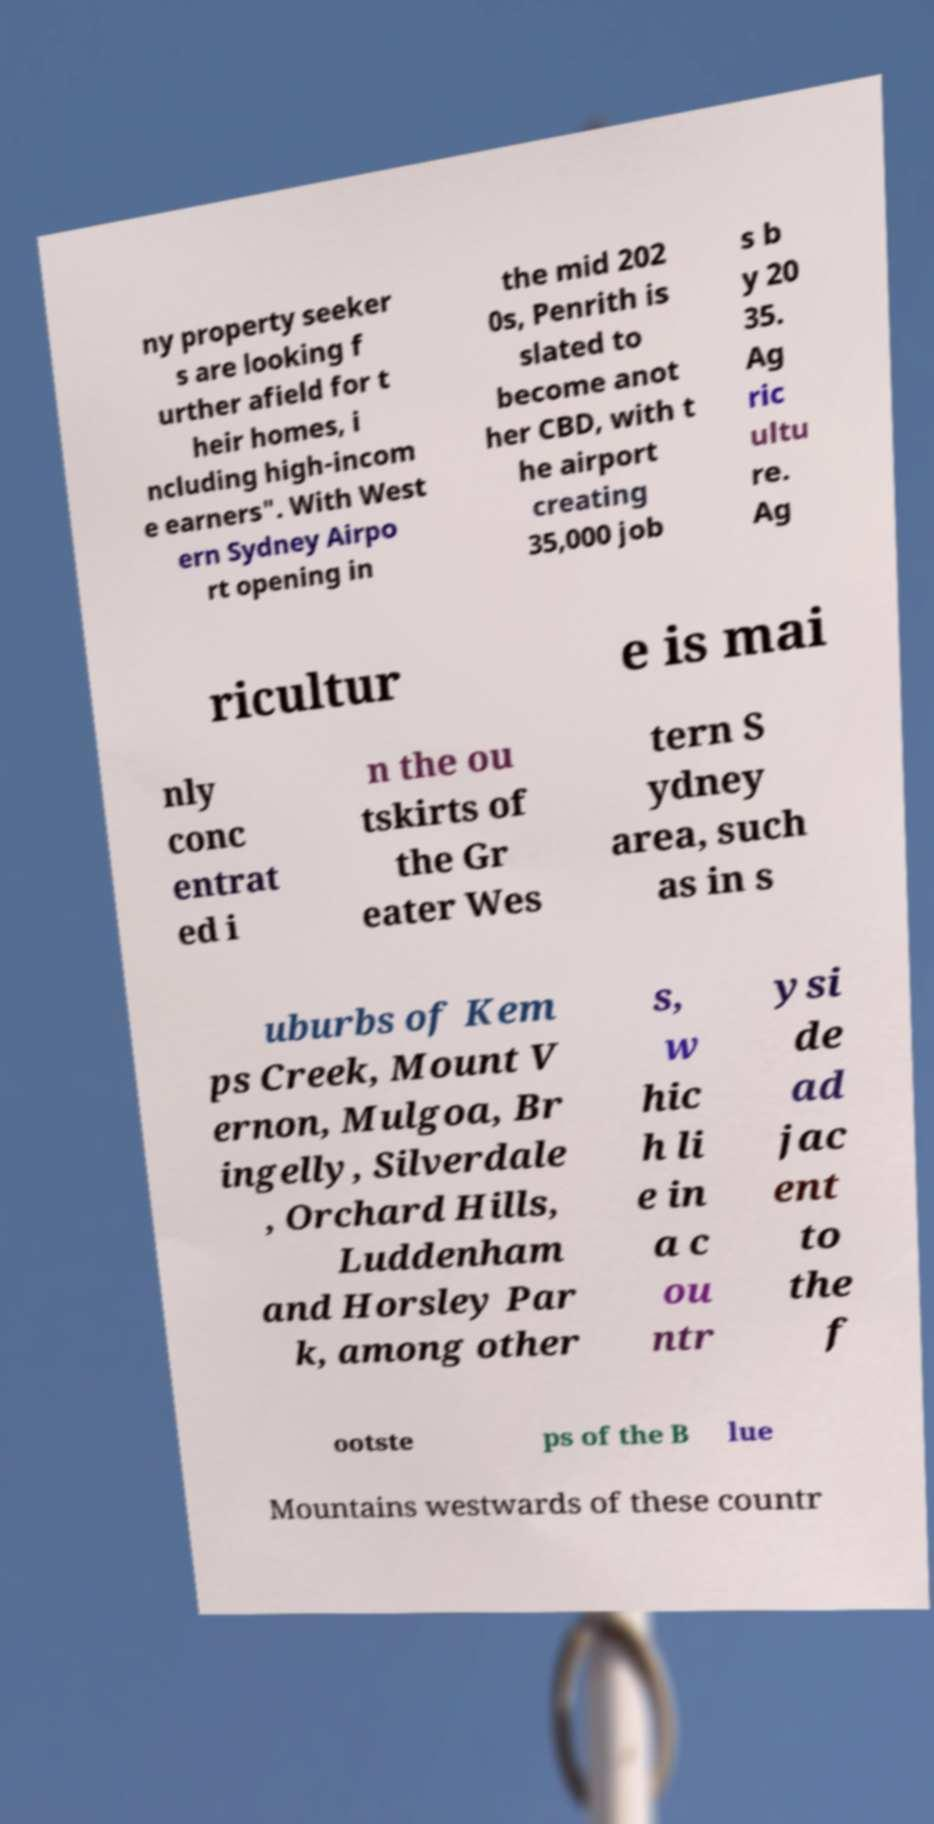Could you extract and type out the text from this image? ny property seeker s are looking f urther afield for t heir homes, i ncluding high-incom e earners". With West ern Sydney Airpo rt opening in the mid 202 0s, Penrith is slated to become anot her CBD, with t he airport creating 35,000 job s b y 20 35. Ag ric ultu re. Ag ricultur e is mai nly conc entrat ed i n the ou tskirts of the Gr eater Wes tern S ydney area, such as in s uburbs of Kem ps Creek, Mount V ernon, Mulgoa, Br ingelly, Silverdale , Orchard Hills, Luddenham and Horsley Par k, among other s, w hic h li e in a c ou ntr ysi de ad jac ent to the f ootste ps of the B lue Mountains westwards of these countr 